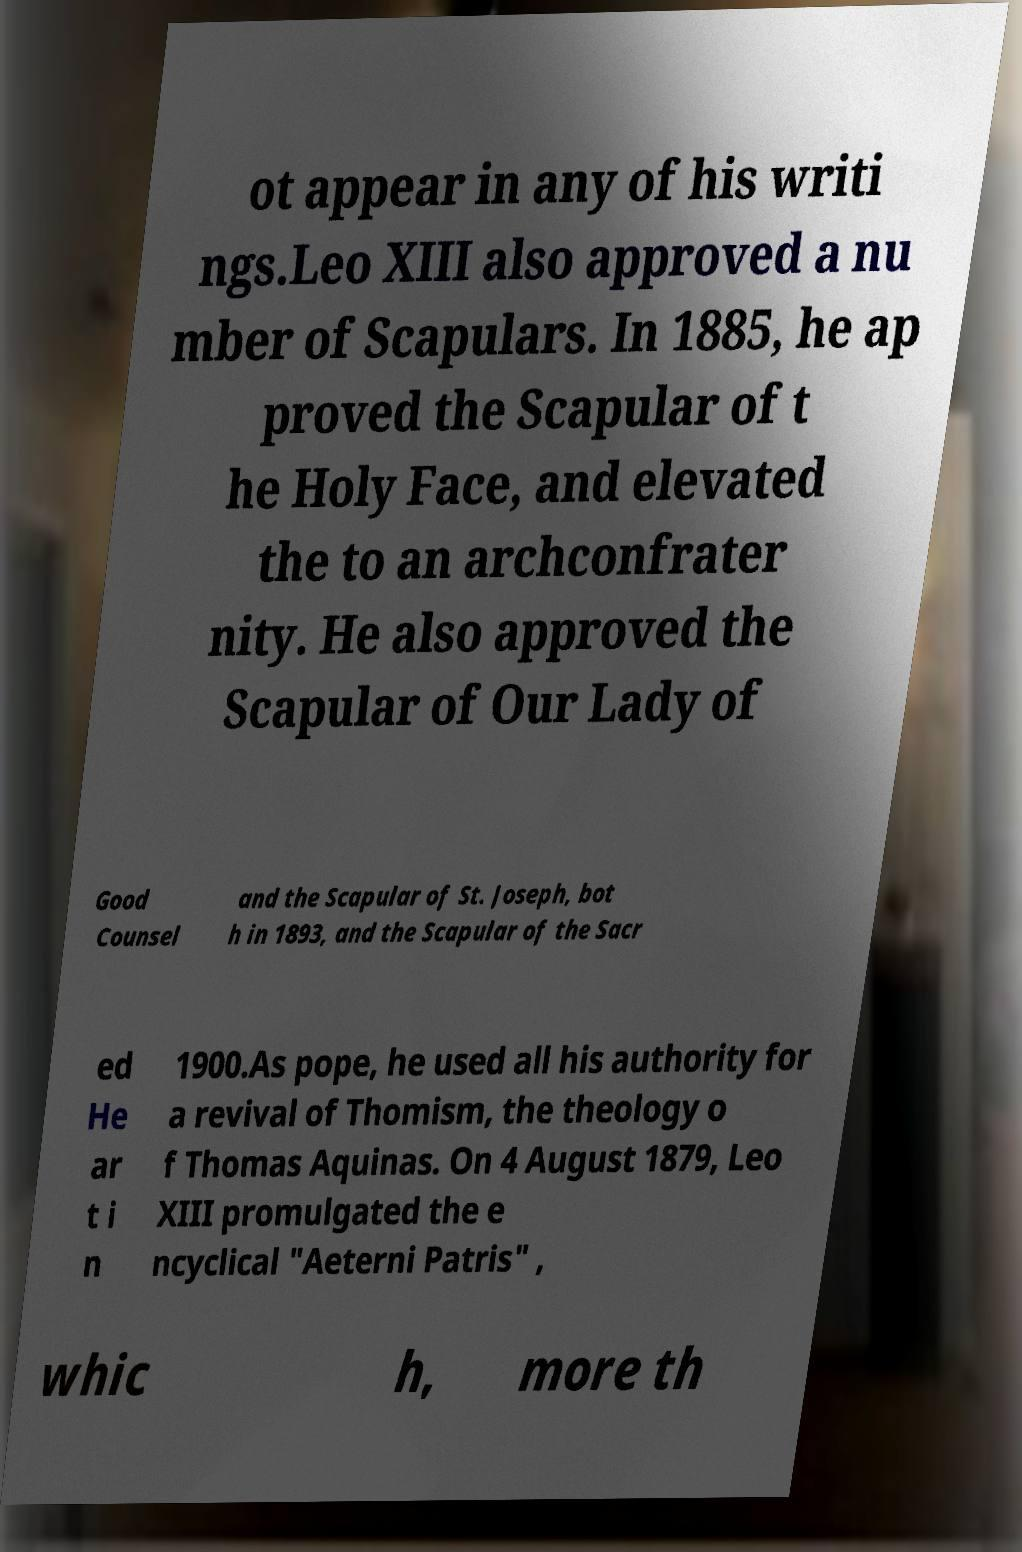For documentation purposes, I need the text within this image transcribed. Could you provide that? ot appear in any of his writi ngs.Leo XIII also approved a nu mber of Scapulars. In 1885, he ap proved the Scapular of t he Holy Face, and elevated the to an archconfrater nity. He also approved the Scapular of Our Lady of Good Counsel and the Scapular of St. Joseph, bot h in 1893, and the Scapular of the Sacr ed He ar t i n 1900.As pope, he used all his authority for a revival of Thomism, the theology o f Thomas Aquinas. On 4 August 1879, Leo XIII promulgated the e ncyclical "Aeterni Patris" , whic h, more th 